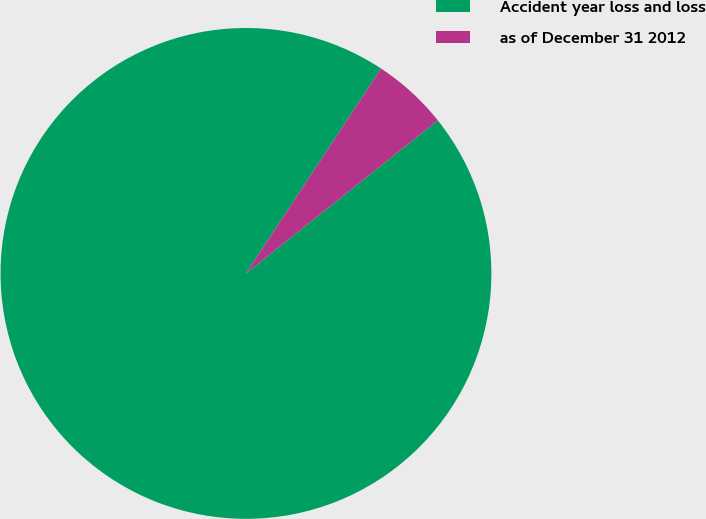Convert chart to OTSL. <chart><loc_0><loc_0><loc_500><loc_500><pie_chart><fcel>Accident year loss and loss<fcel>as of December 31 2012<nl><fcel>94.99%<fcel>5.01%<nl></chart> 